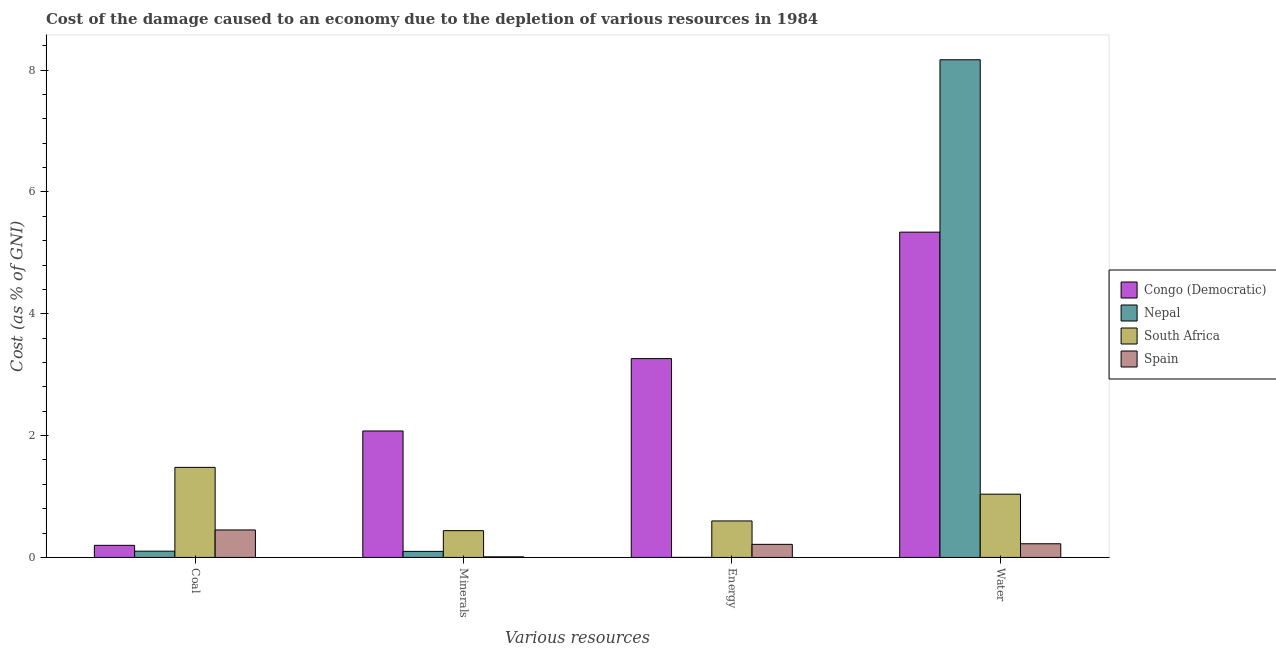How many different coloured bars are there?
Make the answer very short. 4. How many groups of bars are there?
Offer a terse response. 4. Are the number of bars per tick equal to the number of legend labels?
Ensure brevity in your answer.  Yes. How many bars are there on the 1st tick from the right?
Offer a very short reply. 4. What is the label of the 1st group of bars from the left?
Your answer should be compact. Coal. What is the cost of damage due to depletion of minerals in Spain?
Offer a very short reply. 0.01. Across all countries, what is the maximum cost of damage due to depletion of minerals?
Your answer should be compact. 2.08. Across all countries, what is the minimum cost of damage due to depletion of coal?
Provide a short and direct response. 0.1. In which country was the cost of damage due to depletion of minerals maximum?
Provide a succinct answer. Congo (Democratic). In which country was the cost of damage due to depletion of minerals minimum?
Provide a succinct answer. Spain. What is the total cost of damage due to depletion of coal in the graph?
Keep it short and to the point. 2.23. What is the difference between the cost of damage due to depletion of minerals in Congo (Democratic) and that in Nepal?
Make the answer very short. 1.98. What is the difference between the cost of damage due to depletion of energy in Congo (Democratic) and the cost of damage due to depletion of water in South Africa?
Offer a very short reply. 2.23. What is the average cost of damage due to depletion of water per country?
Give a very brief answer. 3.69. What is the difference between the cost of damage due to depletion of water and cost of damage due to depletion of coal in Spain?
Offer a very short reply. -0.23. What is the ratio of the cost of damage due to depletion of coal in Spain to that in South Africa?
Offer a very short reply. 0.31. Is the difference between the cost of damage due to depletion of water in Nepal and Spain greater than the difference between the cost of damage due to depletion of coal in Nepal and Spain?
Keep it short and to the point. Yes. What is the difference between the highest and the second highest cost of damage due to depletion of coal?
Your response must be concise. 1.03. What is the difference between the highest and the lowest cost of damage due to depletion of water?
Provide a succinct answer. 7.95. Is the sum of the cost of damage due to depletion of water in Congo (Democratic) and South Africa greater than the maximum cost of damage due to depletion of minerals across all countries?
Make the answer very short. Yes. Is it the case that in every country, the sum of the cost of damage due to depletion of coal and cost of damage due to depletion of water is greater than the sum of cost of damage due to depletion of minerals and cost of damage due to depletion of energy?
Give a very brief answer. Yes. What does the 3rd bar from the right in Coal represents?
Provide a succinct answer. Nepal. Is it the case that in every country, the sum of the cost of damage due to depletion of coal and cost of damage due to depletion of minerals is greater than the cost of damage due to depletion of energy?
Make the answer very short. No. How many bars are there?
Give a very brief answer. 16. How many countries are there in the graph?
Offer a terse response. 4. Are the values on the major ticks of Y-axis written in scientific E-notation?
Provide a short and direct response. No. Does the graph contain any zero values?
Your answer should be compact. No. What is the title of the graph?
Provide a short and direct response. Cost of the damage caused to an economy due to the depletion of various resources in 1984 . What is the label or title of the X-axis?
Give a very brief answer. Various resources. What is the label or title of the Y-axis?
Provide a succinct answer. Cost (as % of GNI). What is the Cost (as % of GNI) of Congo (Democratic) in Coal?
Make the answer very short. 0.2. What is the Cost (as % of GNI) in Nepal in Coal?
Your answer should be compact. 0.1. What is the Cost (as % of GNI) of South Africa in Coal?
Provide a short and direct response. 1.48. What is the Cost (as % of GNI) in Spain in Coal?
Make the answer very short. 0.45. What is the Cost (as % of GNI) of Congo (Democratic) in Minerals?
Your answer should be compact. 2.08. What is the Cost (as % of GNI) in Nepal in Minerals?
Your answer should be very brief. 0.1. What is the Cost (as % of GNI) in South Africa in Minerals?
Your response must be concise. 0.44. What is the Cost (as % of GNI) in Spain in Minerals?
Your answer should be compact. 0.01. What is the Cost (as % of GNI) of Congo (Democratic) in Energy?
Offer a very short reply. 3.26. What is the Cost (as % of GNI) in Nepal in Energy?
Ensure brevity in your answer.  0. What is the Cost (as % of GNI) in South Africa in Energy?
Your answer should be very brief. 0.6. What is the Cost (as % of GNI) of Spain in Energy?
Keep it short and to the point. 0.21. What is the Cost (as % of GNI) of Congo (Democratic) in Water?
Offer a very short reply. 5.34. What is the Cost (as % of GNI) in Nepal in Water?
Ensure brevity in your answer.  8.17. What is the Cost (as % of GNI) in South Africa in Water?
Your response must be concise. 1.04. What is the Cost (as % of GNI) of Spain in Water?
Provide a short and direct response. 0.22. Across all Various resources, what is the maximum Cost (as % of GNI) in Congo (Democratic)?
Your response must be concise. 5.34. Across all Various resources, what is the maximum Cost (as % of GNI) of Nepal?
Provide a short and direct response. 8.17. Across all Various resources, what is the maximum Cost (as % of GNI) of South Africa?
Offer a terse response. 1.48. Across all Various resources, what is the maximum Cost (as % of GNI) in Spain?
Make the answer very short. 0.45. Across all Various resources, what is the minimum Cost (as % of GNI) in Congo (Democratic)?
Provide a short and direct response. 0.2. Across all Various resources, what is the minimum Cost (as % of GNI) of Nepal?
Your answer should be very brief. 0. Across all Various resources, what is the minimum Cost (as % of GNI) of South Africa?
Your response must be concise. 0.44. Across all Various resources, what is the minimum Cost (as % of GNI) in Spain?
Make the answer very short. 0.01. What is the total Cost (as % of GNI) of Congo (Democratic) in the graph?
Ensure brevity in your answer.  10.88. What is the total Cost (as % of GNI) of Nepal in the graph?
Offer a terse response. 8.37. What is the total Cost (as % of GNI) of South Africa in the graph?
Your answer should be very brief. 3.56. What is the total Cost (as % of GNI) in Spain in the graph?
Offer a terse response. 0.9. What is the difference between the Cost (as % of GNI) of Congo (Democratic) in Coal and that in Minerals?
Offer a terse response. -1.88. What is the difference between the Cost (as % of GNI) of Nepal in Coal and that in Minerals?
Make the answer very short. 0. What is the difference between the Cost (as % of GNI) of South Africa in Coal and that in Minerals?
Provide a short and direct response. 1.04. What is the difference between the Cost (as % of GNI) of Spain in Coal and that in Minerals?
Ensure brevity in your answer.  0.44. What is the difference between the Cost (as % of GNI) in Congo (Democratic) in Coal and that in Energy?
Your answer should be very brief. -3.07. What is the difference between the Cost (as % of GNI) in Nepal in Coal and that in Energy?
Give a very brief answer. 0.1. What is the difference between the Cost (as % of GNI) in South Africa in Coal and that in Energy?
Offer a very short reply. 0.88. What is the difference between the Cost (as % of GNI) of Spain in Coal and that in Energy?
Give a very brief answer. 0.24. What is the difference between the Cost (as % of GNI) in Congo (Democratic) in Coal and that in Water?
Your response must be concise. -5.14. What is the difference between the Cost (as % of GNI) in Nepal in Coal and that in Water?
Your response must be concise. -8.07. What is the difference between the Cost (as % of GNI) of South Africa in Coal and that in Water?
Keep it short and to the point. 0.44. What is the difference between the Cost (as % of GNI) in Spain in Coal and that in Water?
Your response must be concise. 0.23. What is the difference between the Cost (as % of GNI) in Congo (Democratic) in Minerals and that in Energy?
Your response must be concise. -1.19. What is the difference between the Cost (as % of GNI) in Nepal in Minerals and that in Energy?
Your answer should be compact. 0.1. What is the difference between the Cost (as % of GNI) in South Africa in Minerals and that in Energy?
Your answer should be very brief. -0.16. What is the difference between the Cost (as % of GNI) in Spain in Minerals and that in Energy?
Your response must be concise. -0.2. What is the difference between the Cost (as % of GNI) of Congo (Democratic) in Minerals and that in Water?
Offer a very short reply. -3.26. What is the difference between the Cost (as % of GNI) in Nepal in Minerals and that in Water?
Offer a very short reply. -8.07. What is the difference between the Cost (as % of GNI) in South Africa in Minerals and that in Water?
Your answer should be compact. -0.6. What is the difference between the Cost (as % of GNI) of Spain in Minerals and that in Water?
Your answer should be very brief. -0.21. What is the difference between the Cost (as % of GNI) in Congo (Democratic) in Energy and that in Water?
Give a very brief answer. -2.08. What is the difference between the Cost (as % of GNI) in Nepal in Energy and that in Water?
Provide a succinct answer. -8.17. What is the difference between the Cost (as % of GNI) in South Africa in Energy and that in Water?
Ensure brevity in your answer.  -0.44. What is the difference between the Cost (as % of GNI) of Spain in Energy and that in Water?
Provide a succinct answer. -0.01. What is the difference between the Cost (as % of GNI) in Congo (Democratic) in Coal and the Cost (as % of GNI) in Nepal in Minerals?
Your answer should be compact. 0.1. What is the difference between the Cost (as % of GNI) in Congo (Democratic) in Coal and the Cost (as % of GNI) in South Africa in Minerals?
Make the answer very short. -0.24. What is the difference between the Cost (as % of GNI) in Congo (Democratic) in Coal and the Cost (as % of GNI) in Spain in Minerals?
Give a very brief answer. 0.19. What is the difference between the Cost (as % of GNI) in Nepal in Coal and the Cost (as % of GNI) in South Africa in Minerals?
Your answer should be compact. -0.34. What is the difference between the Cost (as % of GNI) in Nepal in Coal and the Cost (as % of GNI) in Spain in Minerals?
Your answer should be compact. 0.09. What is the difference between the Cost (as % of GNI) in South Africa in Coal and the Cost (as % of GNI) in Spain in Minerals?
Your answer should be compact. 1.47. What is the difference between the Cost (as % of GNI) in Congo (Democratic) in Coal and the Cost (as % of GNI) in Nepal in Energy?
Provide a short and direct response. 0.2. What is the difference between the Cost (as % of GNI) in Congo (Democratic) in Coal and the Cost (as % of GNI) in South Africa in Energy?
Your answer should be compact. -0.4. What is the difference between the Cost (as % of GNI) of Congo (Democratic) in Coal and the Cost (as % of GNI) of Spain in Energy?
Ensure brevity in your answer.  -0.02. What is the difference between the Cost (as % of GNI) of Nepal in Coal and the Cost (as % of GNI) of South Africa in Energy?
Keep it short and to the point. -0.5. What is the difference between the Cost (as % of GNI) of Nepal in Coal and the Cost (as % of GNI) of Spain in Energy?
Offer a very short reply. -0.11. What is the difference between the Cost (as % of GNI) in South Africa in Coal and the Cost (as % of GNI) in Spain in Energy?
Offer a very short reply. 1.26. What is the difference between the Cost (as % of GNI) of Congo (Democratic) in Coal and the Cost (as % of GNI) of Nepal in Water?
Ensure brevity in your answer.  -7.97. What is the difference between the Cost (as % of GNI) in Congo (Democratic) in Coal and the Cost (as % of GNI) in South Africa in Water?
Keep it short and to the point. -0.84. What is the difference between the Cost (as % of GNI) of Congo (Democratic) in Coal and the Cost (as % of GNI) of Spain in Water?
Offer a very short reply. -0.03. What is the difference between the Cost (as % of GNI) in Nepal in Coal and the Cost (as % of GNI) in South Africa in Water?
Make the answer very short. -0.94. What is the difference between the Cost (as % of GNI) of Nepal in Coal and the Cost (as % of GNI) of Spain in Water?
Offer a terse response. -0.12. What is the difference between the Cost (as % of GNI) of South Africa in Coal and the Cost (as % of GNI) of Spain in Water?
Give a very brief answer. 1.25. What is the difference between the Cost (as % of GNI) of Congo (Democratic) in Minerals and the Cost (as % of GNI) of Nepal in Energy?
Offer a terse response. 2.08. What is the difference between the Cost (as % of GNI) in Congo (Democratic) in Minerals and the Cost (as % of GNI) in South Africa in Energy?
Make the answer very short. 1.48. What is the difference between the Cost (as % of GNI) in Congo (Democratic) in Minerals and the Cost (as % of GNI) in Spain in Energy?
Provide a short and direct response. 1.86. What is the difference between the Cost (as % of GNI) in Nepal in Minerals and the Cost (as % of GNI) in South Africa in Energy?
Offer a terse response. -0.5. What is the difference between the Cost (as % of GNI) in Nepal in Minerals and the Cost (as % of GNI) in Spain in Energy?
Ensure brevity in your answer.  -0.12. What is the difference between the Cost (as % of GNI) of South Africa in Minerals and the Cost (as % of GNI) of Spain in Energy?
Offer a terse response. 0.22. What is the difference between the Cost (as % of GNI) of Congo (Democratic) in Minerals and the Cost (as % of GNI) of Nepal in Water?
Make the answer very short. -6.09. What is the difference between the Cost (as % of GNI) in Congo (Democratic) in Minerals and the Cost (as % of GNI) in South Africa in Water?
Provide a short and direct response. 1.04. What is the difference between the Cost (as % of GNI) in Congo (Democratic) in Minerals and the Cost (as % of GNI) in Spain in Water?
Your answer should be compact. 1.85. What is the difference between the Cost (as % of GNI) in Nepal in Minerals and the Cost (as % of GNI) in South Africa in Water?
Your answer should be compact. -0.94. What is the difference between the Cost (as % of GNI) in Nepal in Minerals and the Cost (as % of GNI) in Spain in Water?
Keep it short and to the point. -0.13. What is the difference between the Cost (as % of GNI) of South Africa in Minerals and the Cost (as % of GNI) of Spain in Water?
Your answer should be compact. 0.21. What is the difference between the Cost (as % of GNI) in Congo (Democratic) in Energy and the Cost (as % of GNI) in Nepal in Water?
Offer a terse response. -4.91. What is the difference between the Cost (as % of GNI) in Congo (Democratic) in Energy and the Cost (as % of GNI) in South Africa in Water?
Give a very brief answer. 2.23. What is the difference between the Cost (as % of GNI) in Congo (Democratic) in Energy and the Cost (as % of GNI) in Spain in Water?
Keep it short and to the point. 3.04. What is the difference between the Cost (as % of GNI) in Nepal in Energy and the Cost (as % of GNI) in South Africa in Water?
Your answer should be very brief. -1.04. What is the difference between the Cost (as % of GNI) in Nepal in Energy and the Cost (as % of GNI) in Spain in Water?
Keep it short and to the point. -0.22. What is the difference between the Cost (as % of GNI) in South Africa in Energy and the Cost (as % of GNI) in Spain in Water?
Your answer should be compact. 0.37. What is the average Cost (as % of GNI) of Congo (Democratic) per Various resources?
Give a very brief answer. 2.72. What is the average Cost (as % of GNI) of Nepal per Various resources?
Your answer should be very brief. 2.09. What is the average Cost (as % of GNI) in South Africa per Various resources?
Provide a short and direct response. 0.89. What is the average Cost (as % of GNI) in Spain per Various resources?
Provide a succinct answer. 0.23. What is the difference between the Cost (as % of GNI) of Congo (Democratic) and Cost (as % of GNI) of Nepal in Coal?
Make the answer very short. 0.1. What is the difference between the Cost (as % of GNI) of Congo (Democratic) and Cost (as % of GNI) of South Africa in Coal?
Make the answer very short. -1.28. What is the difference between the Cost (as % of GNI) of Congo (Democratic) and Cost (as % of GNI) of Spain in Coal?
Keep it short and to the point. -0.25. What is the difference between the Cost (as % of GNI) in Nepal and Cost (as % of GNI) in South Africa in Coal?
Provide a succinct answer. -1.38. What is the difference between the Cost (as % of GNI) of Nepal and Cost (as % of GNI) of Spain in Coal?
Your answer should be very brief. -0.35. What is the difference between the Cost (as % of GNI) of South Africa and Cost (as % of GNI) of Spain in Coal?
Provide a succinct answer. 1.03. What is the difference between the Cost (as % of GNI) of Congo (Democratic) and Cost (as % of GNI) of Nepal in Minerals?
Provide a short and direct response. 1.98. What is the difference between the Cost (as % of GNI) in Congo (Democratic) and Cost (as % of GNI) in South Africa in Minerals?
Make the answer very short. 1.64. What is the difference between the Cost (as % of GNI) in Congo (Democratic) and Cost (as % of GNI) in Spain in Minerals?
Offer a terse response. 2.07. What is the difference between the Cost (as % of GNI) in Nepal and Cost (as % of GNI) in South Africa in Minerals?
Keep it short and to the point. -0.34. What is the difference between the Cost (as % of GNI) in Nepal and Cost (as % of GNI) in Spain in Minerals?
Give a very brief answer. 0.09. What is the difference between the Cost (as % of GNI) in South Africa and Cost (as % of GNI) in Spain in Minerals?
Keep it short and to the point. 0.43. What is the difference between the Cost (as % of GNI) of Congo (Democratic) and Cost (as % of GNI) of Nepal in Energy?
Your answer should be very brief. 3.26. What is the difference between the Cost (as % of GNI) of Congo (Democratic) and Cost (as % of GNI) of South Africa in Energy?
Your answer should be very brief. 2.67. What is the difference between the Cost (as % of GNI) in Congo (Democratic) and Cost (as % of GNI) in Spain in Energy?
Offer a terse response. 3.05. What is the difference between the Cost (as % of GNI) of Nepal and Cost (as % of GNI) of South Africa in Energy?
Provide a short and direct response. -0.6. What is the difference between the Cost (as % of GNI) of Nepal and Cost (as % of GNI) of Spain in Energy?
Offer a very short reply. -0.21. What is the difference between the Cost (as % of GNI) in South Africa and Cost (as % of GNI) in Spain in Energy?
Offer a terse response. 0.38. What is the difference between the Cost (as % of GNI) of Congo (Democratic) and Cost (as % of GNI) of Nepal in Water?
Your response must be concise. -2.83. What is the difference between the Cost (as % of GNI) of Congo (Democratic) and Cost (as % of GNI) of South Africa in Water?
Give a very brief answer. 4.3. What is the difference between the Cost (as % of GNI) of Congo (Democratic) and Cost (as % of GNI) of Spain in Water?
Keep it short and to the point. 5.12. What is the difference between the Cost (as % of GNI) of Nepal and Cost (as % of GNI) of South Africa in Water?
Provide a short and direct response. 7.13. What is the difference between the Cost (as % of GNI) of Nepal and Cost (as % of GNI) of Spain in Water?
Provide a succinct answer. 7.95. What is the difference between the Cost (as % of GNI) of South Africa and Cost (as % of GNI) of Spain in Water?
Offer a terse response. 0.81. What is the ratio of the Cost (as % of GNI) of Congo (Democratic) in Coal to that in Minerals?
Keep it short and to the point. 0.1. What is the ratio of the Cost (as % of GNI) of Nepal in Coal to that in Minerals?
Offer a very short reply. 1.04. What is the ratio of the Cost (as % of GNI) in South Africa in Coal to that in Minerals?
Your response must be concise. 3.37. What is the ratio of the Cost (as % of GNI) of Spain in Coal to that in Minerals?
Your answer should be compact. 46.09. What is the ratio of the Cost (as % of GNI) of Congo (Democratic) in Coal to that in Energy?
Keep it short and to the point. 0.06. What is the ratio of the Cost (as % of GNI) in Nepal in Coal to that in Energy?
Ensure brevity in your answer.  218.43. What is the ratio of the Cost (as % of GNI) of South Africa in Coal to that in Energy?
Keep it short and to the point. 2.47. What is the ratio of the Cost (as % of GNI) in Spain in Coal to that in Energy?
Offer a very short reply. 2.1. What is the ratio of the Cost (as % of GNI) of Congo (Democratic) in Coal to that in Water?
Offer a terse response. 0.04. What is the ratio of the Cost (as % of GNI) of Nepal in Coal to that in Water?
Your response must be concise. 0.01. What is the ratio of the Cost (as % of GNI) in South Africa in Coal to that in Water?
Give a very brief answer. 1.42. What is the ratio of the Cost (as % of GNI) in Spain in Coal to that in Water?
Make the answer very short. 2.01. What is the ratio of the Cost (as % of GNI) of Congo (Democratic) in Minerals to that in Energy?
Give a very brief answer. 0.64. What is the ratio of the Cost (as % of GNI) in Nepal in Minerals to that in Energy?
Ensure brevity in your answer.  210.67. What is the ratio of the Cost (as % of GNI) in South Africa in Minerals to that in Energy?
Ensure brevity in your answer.  0.73. What is the ratio of the Cost (as % of GNI) in Spain in Minerals to that in Energy?
Your response must be concise. 0.05. What is the ratio of the Cost (as % of GNI) in Congo (Democratic) in Minerals to that in Water?
Your response must be concise. 0.39. What is the ratio of the Cost (as % of GNI) in Nepal in Minerals to that in Water?
Give a very brief answer. 0.01. What is the ratio of the Cost (as % of GNI) of South Africa in Minerals to that in Water?
Your response must be concise. 0.42. What is the ratio of the Cost (as % of GNI) of Spain in Minerals to that in Water?
Ensure brevity in your answer.  0.04. What is the ratio of the Cost (as % of GNI) in Congo (Democratic) in Energy to that in Water?
Keep it short and to the point. 0.61. What is the ratio of the Cost (as % of GNI) of South Africa in Energy to that in Water?
Give a very brief answer. 0.58. What is the ratio of the Cost (as % of GNI) in Spain in Energy to that in Water?
Provide a succinct answer. 0.96. What is the difference between the highest and the second highest Cost (as % of GNI) of Congo (Democratic)?
Keep it short and to the point. 2.08. What is the difference between the highest and the second highest Cost (as % of GNI) in Nepal?
Your answer should be very brief. 8.07. What is the difference between the highest and the second highest Cost (as % of GNI) in South Africa?
Offer a very short reply. 0.44. What is the difference between the highest and the second highest Cost (as % of GNI) in Spain?
Your response must be concise. 0.23. What is the difference between the highest and the lowest Cost (as % of GNI) in Congo (Democratic)?
Your answer should be compact. 5.14. What is the difference between the highest and the lowest Cost (as % of GNI) of Nepal?
Your response must be concise. 8.17. What is the difference between the highest and the lowest Cost (as % of GNI) of South Africa?
Make the answer very short. 1.04. What is the difference between the highest and the lowest Cost (as % of GNI) in Spain?
Your answer should be compact. 0.44. 